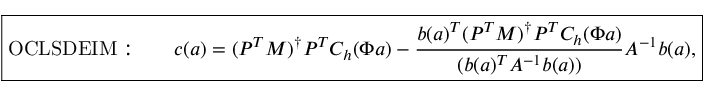Convert formula to latex. <formula><loc_0><loc_0><loc_500><loc_500>\boxed { O C L S D E I M \colon \quad c ( a ) = ( P ^ { T } M ) ^ { \dagger } P ^ { T } C _ { h } ( \Phi a ) - \frac { b ( a ) ^ { T } ( P ^ { T } M ) ^ { \dagger } P ^ { T } C _ { h } ( \Phi a ) } { ( b ( a ) ^ { T } A ^ { - 1 } b ( a ) ) } A ^ { - 1 } b ( a ) , }</formula> 